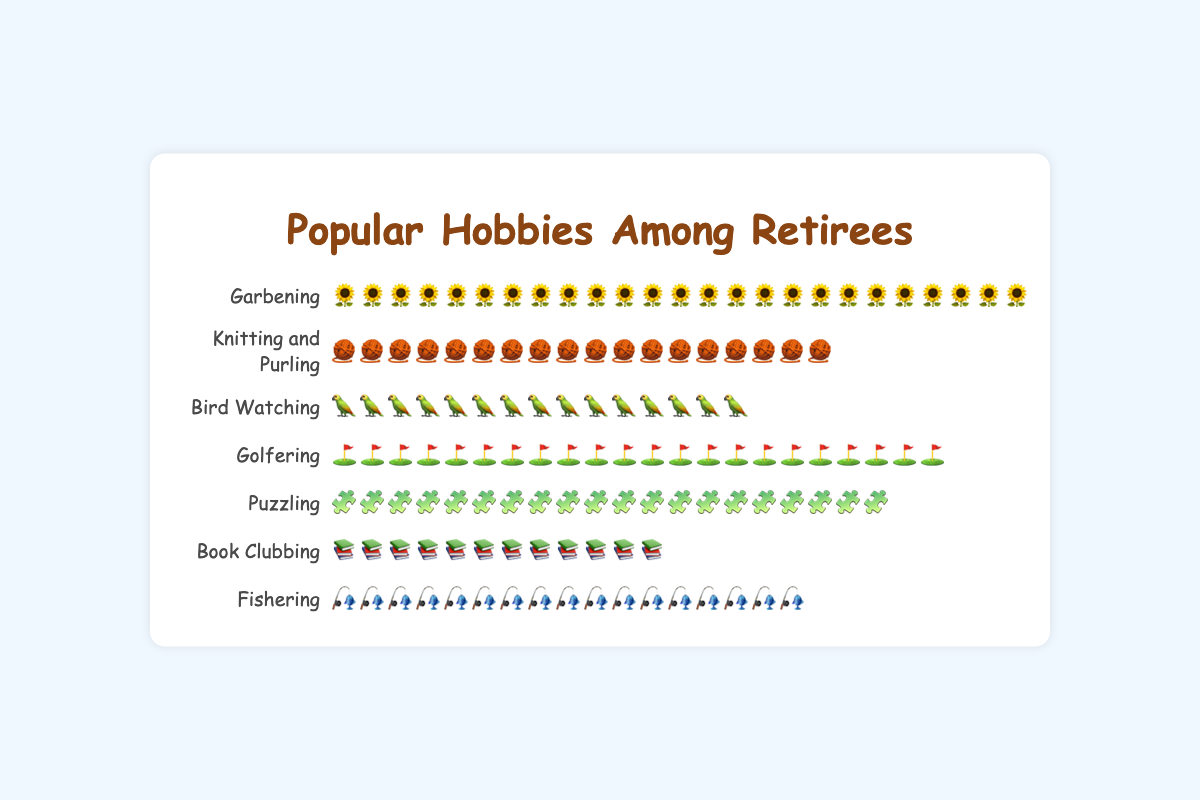What is the title of the plot? The title of the plot is shown at the top center part of the figure, typically in a larger and bold font.
Answer: Popular Hobbies Among Retirees Which hobby has the most icons? Look for the row with the most icons next to the hobby's name. Count the icons if necessary. The one with the largest number of icons is the hobby with the most.
Answer: Garbening How many people are into Book Clubbing? Count the number of icon representations in the row corresponding to 'Book Clubbing'. Each icon represents a person.
Answer: 12 Which hobby has fewer enthusiasts: Knitting and Purling or Fishering? Compare the number of icons for "Knitting and Purling" and "Fishering". The hobby with fewer icons has fewer enthusiasts.
Answer: Fishering If you combine Garbening and Bird Watching, how many people are involved in these two hobbies? Add the number of icons from "Garbening" and "Bird Watching". Garbening has 25 icons, and Bird Watching has 15. So, 25 + 15 = 40
Answer: 40 Is Fishering more popular than Bird Watching? Compare the number of icons between "Fishering" and "Bird Watching". Fishering has 17 icons, and Bird Watching has 15. Fishering has more enthusiasts.
Answer: Yes How many more people are doing Golfering compared to Puzzling? Subtract the number of icons of "Puzzling" from "Golfering". Golfering has 22 icons, and Puzzling has 20. So, 22 - 20 = 2
Answer: 2 What is the total number of participants across all hobbies shown in the plot? Sum the number of icons across all hobby rows. (25 + 18 + 15 + 22 + 20 + 12 + 17)
Answer: 129 Which hobby is the least popular? Identify the row with the fewest icons. The hobby name associated with this row is the least popular.
Answer: Book Clubbing 